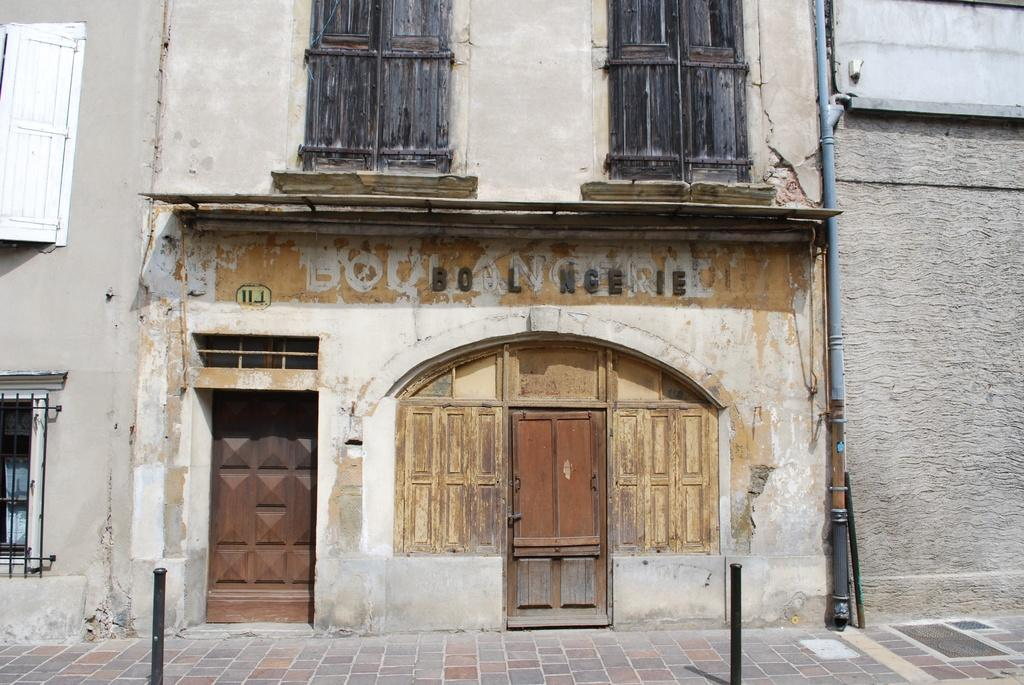What features can be seen on the building in the image? The building has windows and doors. Is there any additional structure attached to the building? Yes, a pipe is attached to the wall of the building. What is located in front of the building? There are rods in front of the building. Can you tell me how much milk the girl is carrying in the image? There is no girl or milk present in the image. How can we help the person in the image? There is no person in the image who needs help. 